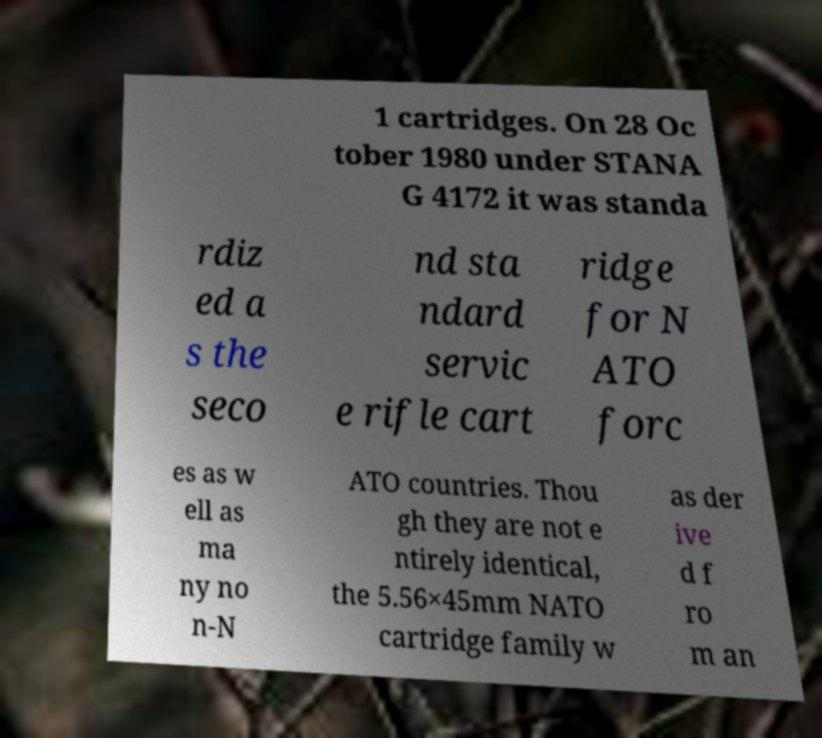I need the written content from this picture converted into text. Can you do that? 1 cartridges. On 28 Oc tober 1980 under STANA G 4172 it was standa rdiz ed a s the seco nd sta ndard servic e rifle cart ridge for N ATO forc es as w ell as ma ny no n-N ATO countries. Thou gh they are not e ntirely identical, the 5.56×45mm NATO cartridge family w as der ive d f ro m an 